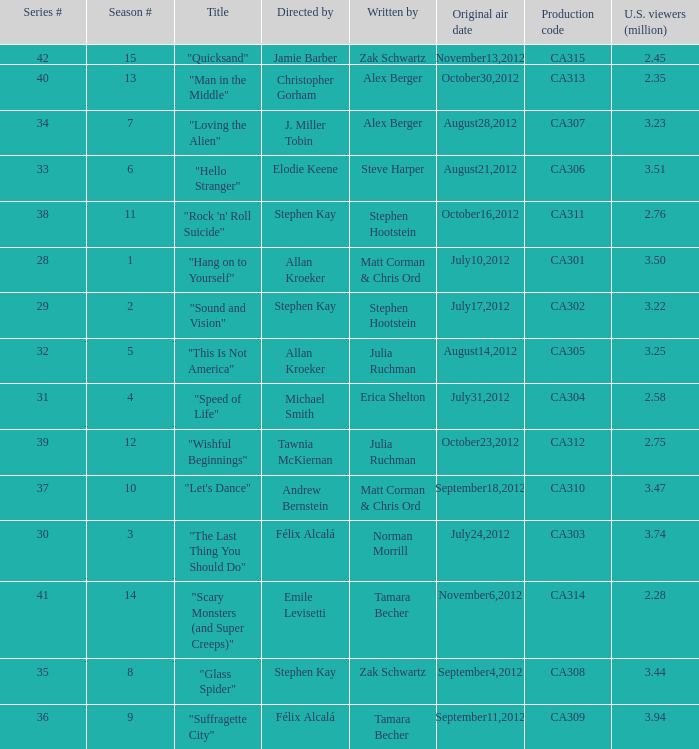Who directed the episode with production code ca303? Félix Alcalá. 